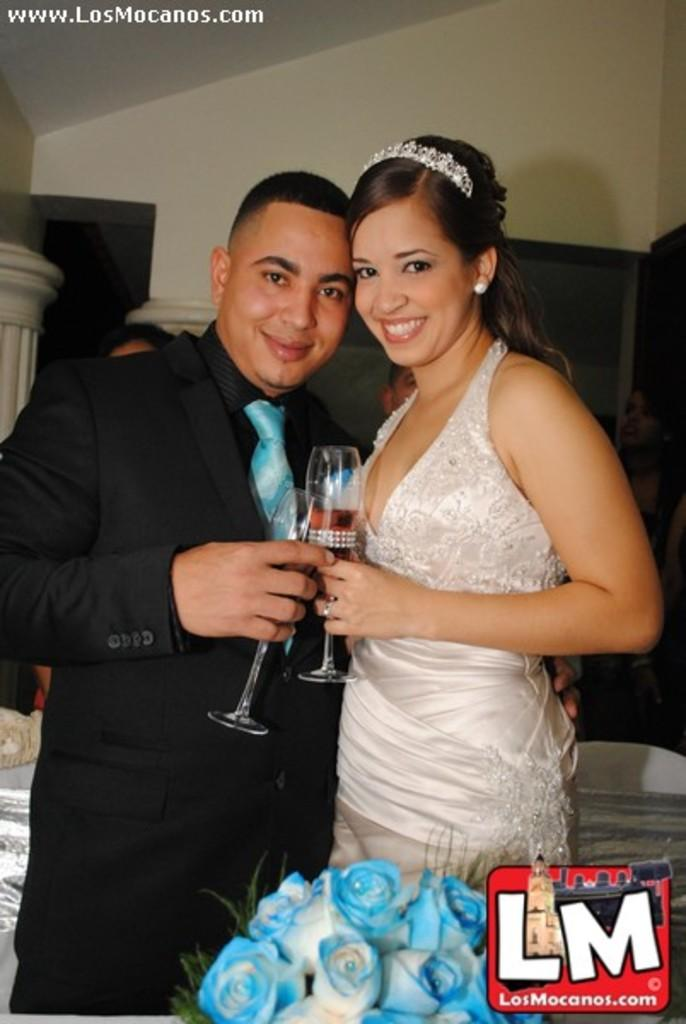How many people are in the image? There are two people in the image. Can you describe the appearance of the guy in the image? The guy is wearing a blue suit. What is the lady in the image wearing? The lady is wearing a white dress. What is the lady holding in the image? The lady is holding glasses. What type of flowers are in front of them? There are blue roses in front of them. What type of soup is being served in the image? There is no soup present in the image. The image features two people, a guy in a blue suit and a lady in a white dress, with the lady holding glasses and blue roses in front of them. 